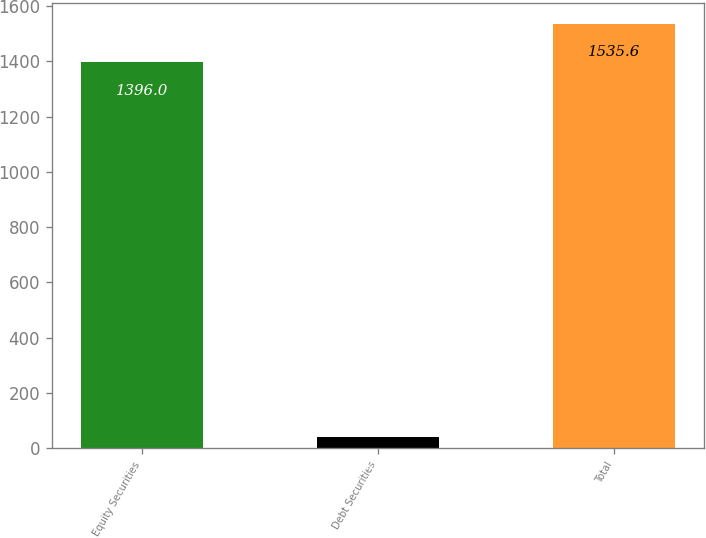Convert chart to OTSL. <chart><loc_0><loc_0><loc_500><loc_500><bar_chart><fcel>Equity Securities<fcel>Debt Securities<fcel>Total<nl><fcel>1396<fcel>41<fcel>1535.6<nl></chart> 